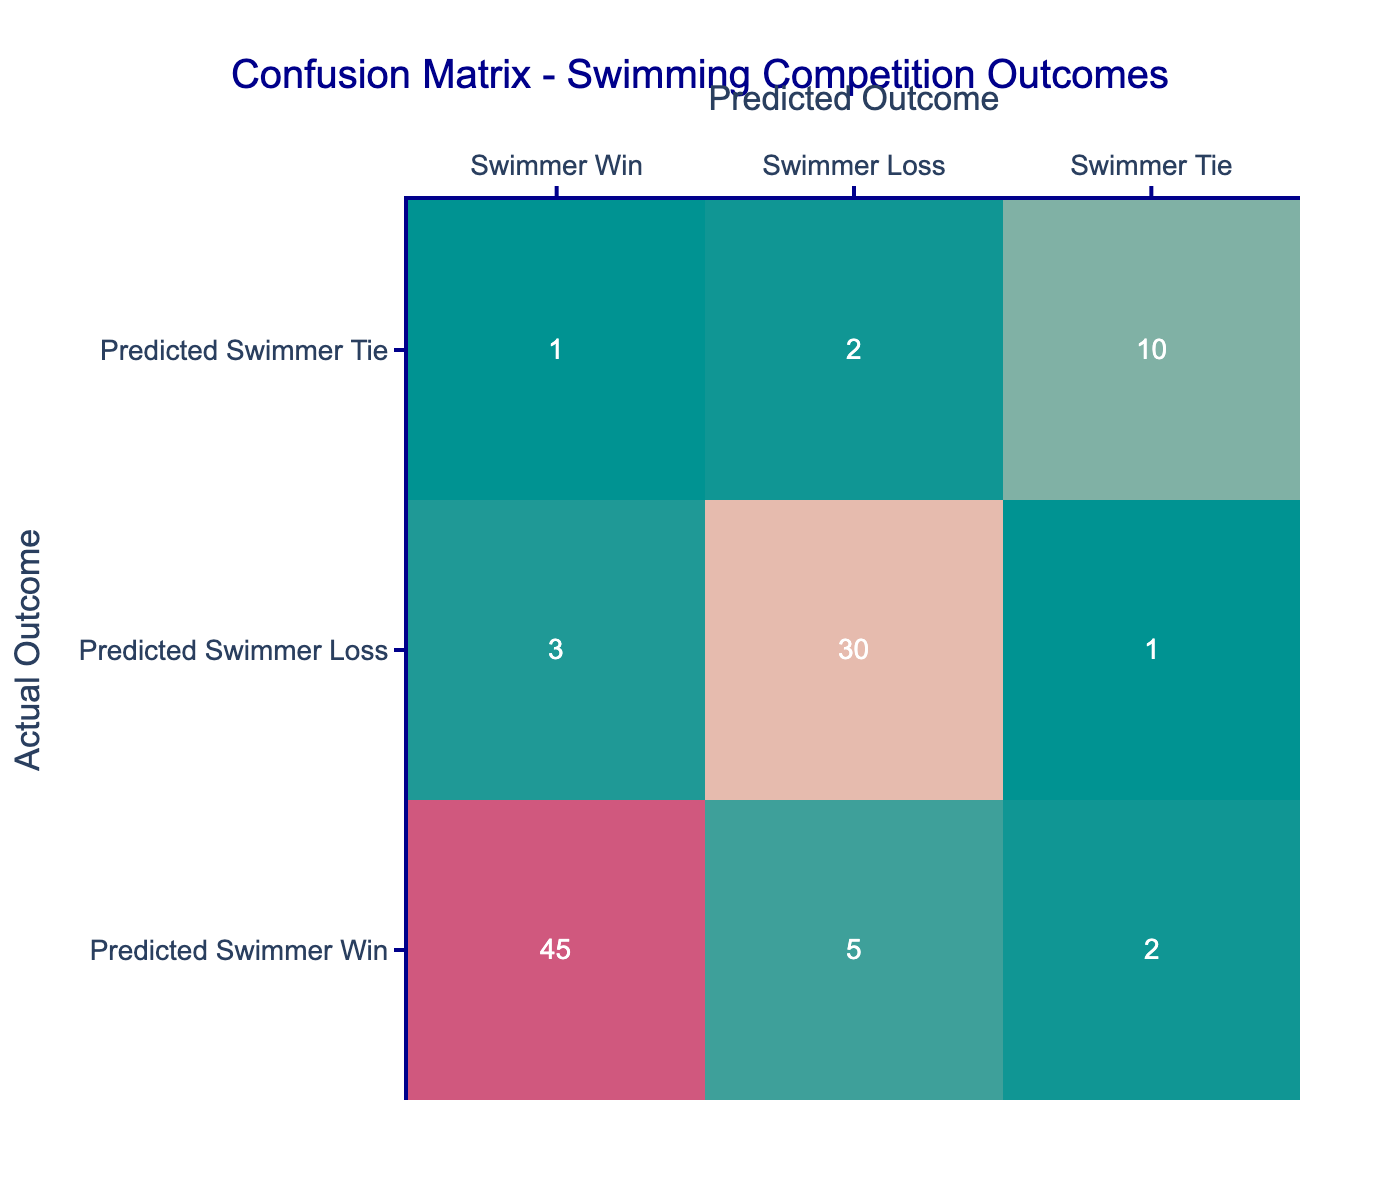What is the total number of predicted swimmer wins? To find the total predicted swimmer wins, we look at the first row of the table, which shows the predicted swimmer win counts against the actual outcomes. We add the values in that row: 45 (actual win) + 5 (actual loss) + 2 (actual tie) = 52.
Answer: 52 How many times were swimmer ties predicted when the outcome was a loss? In the table, we focus on the second column from the left under the "Predicted Swimmer Tie" row, which corresponds to actual outcomes labeled as "Swimmer Loss." The value there is 2.
Answer: 2 What is the percentage of actual swimmer wins that were correctly predicted? To find this percentage, we look at the count of actual swimmer wins that were predicted correctly, which is 45. We also need the total number of actual swimmer wins, losses, and ties: 45 + 5 + 2 + 3 + 30 + 1 + 1 + 2 + 10 = 99. The ratio is (45/99) * 100 = 45.45%.
Answer: 45.45% Did the swimmer lose more often than they won according to the predictions? From the table, the number of predicted swimmer losses is calculated by adding the actual outcomes under "Swimmer Loss" which gives us 30 (predicted win) + 5 (predicted tie) for losses against the swimmer. The actual wins (45) are less than the losses (30), therefore yes, the swimmer lost more often.
Answer: Yes What is the difference between the number of swimmer losses predicted and the number of swimmer wins predicted? To find the difference, we need to subtract the total swimmer wins predicted (which is found from row 1: 45 + 5 + 2 = 52) from the total swimmer losses predicted (which is in the second row: 3 + 30 + 1 = 34), resulting in 34 - 52 = -18. This indicates the swimmer wins predicted exceed the swimmer losses predicted by 18.
Answer: -18 How many total actual outcomes were tied? Ties are recorded in the third row of the table "Swimmer Tie." We count the values under this row: adding 2 (predicted loss) + 10 (predicted tie) gives 12. Thus, there were 12 actual outcomes that were tied.
Answer: 12 What is the overall accuracy of the predictions? Accuracy can be calculated by adding the correctly predicted outcomes: wins (45) + ties (10) and dividing by the total number of outcomes (99): (45 + 10) / 99 = 55/99 ≈ 0.5556 or ≈ 55.56%.
Answer: 55.56% Was there a higher occurrence of actual swimmer losses than ties? Checking the table, to confirm, we note that actual losses (let's calculate: sum of 5 + 3 + 30 + 2 is 40) are higher than the actual ties (sum of 2 + 10 is 12), confirming that losses outnumber ties.
Answer: Yes What was the highest number of predicted swimmer losses shown in the confusion matrix? Looking at the confusion matrix, the highest number of predicted swimmer losses is the value in the second row under "Swimmer Loss," which is 30.
Answer: 30 